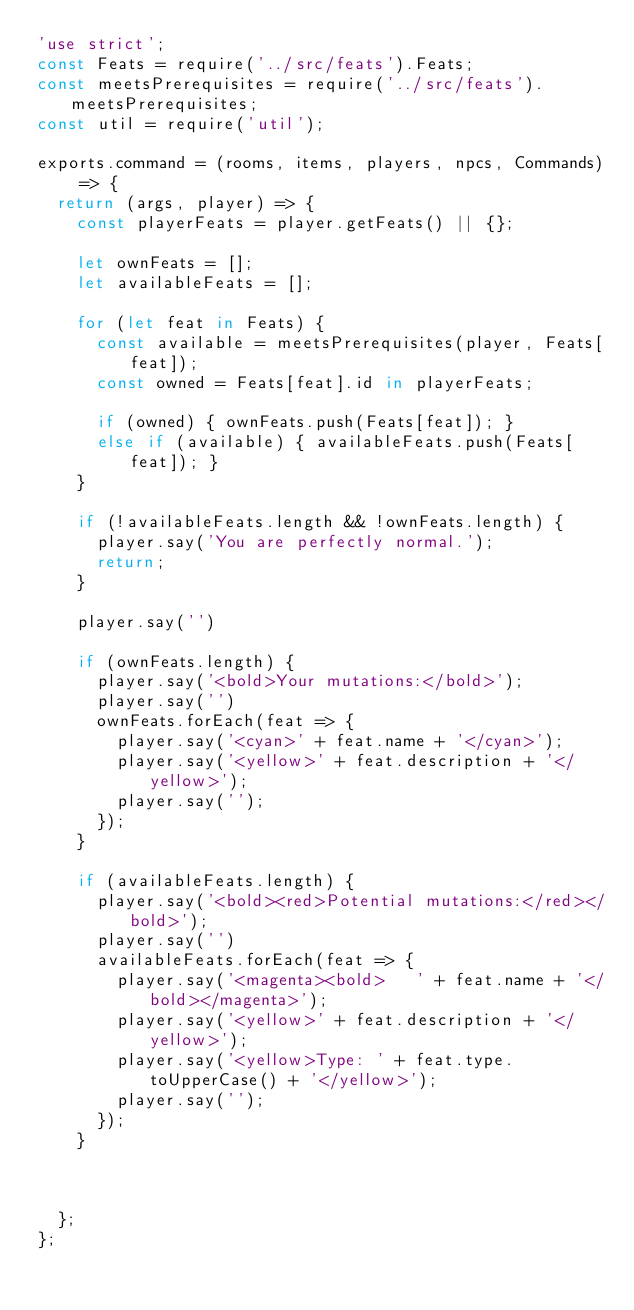Convert code to text. <code><loc_0><loc_0><loc_500><loc_500><_JavaScript_>'use strict';
const Feats = require('../src/feats').Feats;
const meetsPrerequisites = require('../src/feats').meetsPrerequisites;
const util = require('util');

exports.command = (rooms, items, players, npcs, Commands) => {
  return (args, player) => {
    const playerFeats = player.getFeats() || {};

    let ownFeats = [];
    let availableFeats = [];

    for (let feat in Feats) {
      const available = meetsPrerequisites(player, Feats[feat]);
      const owned = Feats[feat].id in playerFeats;

      if (owned) { ownFeats.push(Feats[feat]); }
      else if (available) { availableFeats.push(Feats[feat]); }
    }

    if (!availableFeats.length && !ownFeats.length) {
      player.say('You are perfectly normal.');
      return;
    }

    player.say('')

    if (ownFeats.length) {
      player.say('<bold>Your mutations:</bold>');
      player.say('')
      ownFeats.forEach(feat => {
        player.say('<cyan>' + feat.name + '</cyan>');
        player.say('<yellow>' + feat.description + '</yellow>');
        player.say('');
      });
    }

    if (availableFeats.length) {
      player.say('<bold><red>Potential mutations:</red></bold>');
      player.say('')
      availableFeats.forEach(feat => {
        player.say('<magenta><bold>   ' + feat.name + '</bold></magenta>');
        player.say('<yellow>' + feat.description + '</yellow>');
        player.say('<yellow>Type: ' + feat.type.toUpperCase() + '</yellow>');
        player.say('');
      });
    }



  };
};
</code> 